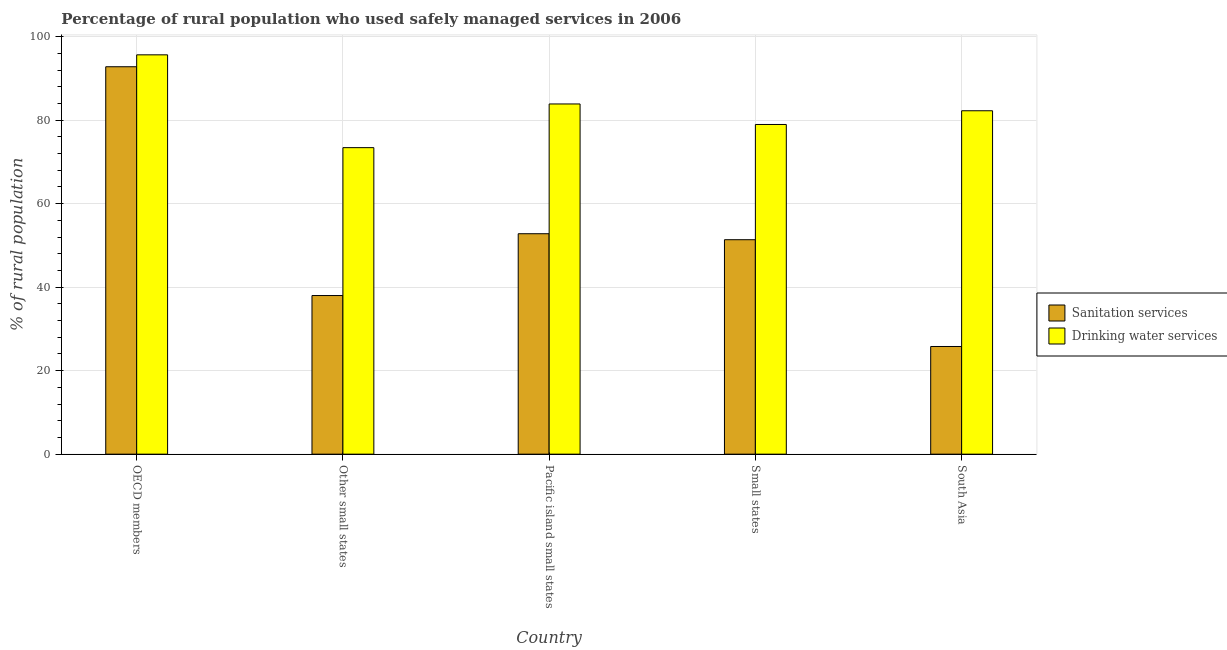How many groups of bars are there?
Offer a terse response. 5. Are the number of bars per tick equal to the number of legend labels?
Offer a very short reply. Yes. Are the number of bars on each tick of the X-axis equal?
Keep it short and to the point. Yes. How many bars are there on the 5th tick from the left?
Provide a succinct answer. 2. What is the label of the 3rd group of bars from the left?
Make the answer very short. Pacific island small states. In how many cases, is the number of bars for a given country not equal to the number of legend labels?
Ensure brevity in your answer.  0. What is the percentage of rural population who used drinking water services in South Asia?
Ensure brevity in your answer.  82.26. Across all countries, what is the maximum percentage of rural population who used sanitation services?
Your response must be concise. 92.8. Across all countries, what is the minimum percentage of rural population who used sanitation services?
Make the answer very short. 25.79. In which country was the percentage of rural population who used drinking water services maximum?
Keep it short and to the point. OECD members. What is the total percentage of rural population who used sanitation services in the graph?
Give a very brief answer. 260.76. What is the difference between the percentage of rural population who used sanitation services in Pacific island small states and that in South Asia?
Your answer should be very brief. 27.01. What is the difference between the percentage of rural population who used drinking water services in Pacific island small states and the percentage of rural population who used sanitation services in OECD members?
Offer a terse response. -8.92. What is the average percentage of rural population who used drinking water services per country?
Your answer should be very brief. 82.84. What is the difference between the percentage of rural population who used sanitation services and percentage of rural population who used drinking water services in Pacific island small states?
Offer a terse response. -31.08. What is the ratio of the percentage of rural population who used drinking water services in Other small states to that in Small states?
Provide a succinct answer. 0.93. Is the difference between the percentage of rural population who used sanitation services in OECD members and Other small states greater than the difference between the percentage of rural population who used drinking water services in OECD members and Other small states?
Keep it short and to the point. Yes. What is the difference between the highest and the second highest percentage of rural population who used sanitation services?
Provide a succinct answer. 40. What is the difference between the highest and the lowest percentage of rural population who used sanitation services?
Provide a short and direct response. 67.01. What does the 2nd bar from the left in Small states represents?
Your answer should be compact. Drinking water services. What does the 2nd bar from the right in Small states represents?
Your answer should be compact. Sanitation services. Are all the bars in the graph horizontal?
Provide a succinct answer. No. How many countries are there in the graph?
Keep it short and to the point. 5. Does the graph contain any zero values?
Ensure brevity in your answer.  No. Where does the legend appear in the graph?
Ensure brevity in your answer.  Center right. What is the title of the graph?
Ensure brevity in your answer.  Percentage of rural population who used safely managed services in 2006. What is the label or title of the Y-axis?
Offer a terse response. % of rural population. What is the % of rural population in Sanitation services in OECD members?
Ensure brevity in your answer.  92.8. What is the % of rural population of Drinking water services in OECD members?
Make the answer very short. 95.65. What is the % of rural population of Sanitation services in Other small states?
Keep it short and to the point. 38. What is the % of rural population in Drinking water services in Other small states?
Provide a short and direct response. 73.42. What is the % of rural population of Sanitation services in Pacific island small states?
Make the answer very short. 52.8. What is the % of rural population of Drinking water services in Pacific island small states?
Offer a very short reply. 83.88. What is the % of rural population of Sanitation services in Small states?
Offer a very short reply. 51.37. What is the % of rural population in Drinking water services in Small states?
Make the answer very short. 78.97. What is the % of rural population in Sanitation services in South Asia?
Provide a short and direct response. 25.79. What is the % of rural population in Drinking water services in South Asia?
Offer a terse response. 82.26. Across all countries, what is the maximum % of rural population in Sanitation services?
Offer a very short reply. 92.8. Across all countries, what is the maximum % of rural population of Drinking water services?
Ensure brevity in your answer.  95.65. Across all countries, what is the minimum % of rural population of Sanitation services?
Provide a short and direct response. 25.79. Across all countries, what is the minimum % of rural population in Drinking water services?
Ensure brevity in your answer.  73.42. What is the total % of rural population in Sanitation services in the graph?
Offer a terse response. 260.76. What is the total % of rural population of Drinking water services in the graph?
Provide a succinct answer. 414.19. What is the difference between the % of rural population in Sanitation services in OECD members and that in Other small states?
Ensure brevity in your answer.  54.8. What is the difference between the % of rural population of Drinking water services in OECD members and that in Other small states?
Provide a short and direct response. 22.23. What is the difference between the % of rural population in Sanitation services in OECD members and that in Pacific island small states?
Provide a short and direct response. 40. What is the difference between the % of rural population in Drinking water services in OECD members and that in Pacific island small states?
Ensure brevity in your answer.  11.77. What is the difference between the % of rural population in Sanitation services in OECD members and that in Small states?
Ensure brevity in your answer.  41.43. What is the difference between the % of rural population in Drinking water services in OECD members and that in Small states?
Your answer should be compact. 16.68. What is the difference between the % of rural population of Sanitation services in OECD members and that in South Asia?
Offer a very short reply. 67.01. What is the difference between the % of rural population in Drinking water services in OECD members and that in South Asia?
Make the answer very short. 13.4. What is the difference between the % of rural population of Sanitation services in Other small states and that in Pacific island small states?
Offer a very short reply. -14.8. What is the difference between the % of rural population of Drinking water services in Other small states and that in Pacific island small states?
Your response must be concise. -10.46. What is the difference between the % of rural population of Sanitation services in Other small states and that in Small states?
Your answer should be compact. -13.37. What is the difference between the % of rural population of Drinking water services in Other small states and that in Small states?
Your answer should be very brief. -5.55. What is the difference between the % of rural population of Sanitation services in Other small states and that in South Asia?
Your answer should be compact. 12.21. What is the difference between the % of rural population of Drinking water services in Other small states and that in South Asia?
Provide a succinct answer. -8.83. What is the difference between the % of rural population in Sanitation services in Pacific island small states and that in Small states?
Provide a succinct answer. 1.43. What is the difference between the % of rural population of Drinking water services in Pacific island small states and that in Small states?
Your answer should be very brief. 4.91. What is the difference between the % of rural population in Sanitation services in Pacific island small states and that in South Asia?
Provide a succinct answer. 27.01. What is the difference between the % of rural population in Drinking water services in Pacific island small states and that in South Asia?
Your answer should be very brief. 1.63. What is the difference between the % of rural population of Sanitation services in Small states and that in South Asia?
Ensure brevity in your answer.  25.58. What is the difference between the % of rural population in Drinking water services in Small states and that in South Asia?
Provide a succinct answer. -3.28. What is the difference between the % of rural population in Sanitation services in OECD members and the % of rural population in Drinking water services in Other small states?
Offer a very short reply. 19.38. What is the difference between the % of rural population in Sanitation services in OECD members and the % of rural population in Drinking water services in Pacific island small states?
Your answer should be very brief. 8.92. What is the difference between the % of rural population in Sanitation services in OECD members and the % of rural population in Drinking water services in Small states?
Your answer should be very brief. 13.83. What is the difference between the % of rural population of Sanitation services in OECD members and the % of rural population of Drinking water services in South Asia?
Provide a succinct answer. 10.54. What is the difference between the % of rural population of Sanitation services in Other small states and the % of rural population of Drinking water services in Pacific island small states?
Your answer should be compact. -45.89. What is the difference between the % of rural population of Sanitation services in Other small states and the % of rural population of Drinking water services in Small states?
Make the answer very short. -40.98. What is the difference between the % of rural population of Sanitation services in Other small states and the % of rural population of Drinking water services in South Asia?
Your response must be concise. -44.26. What is the difference between the % of rural population in Sanitation services in Pacific island small states and the % of rural population in Drinking water services in Small states?
Make the answer very short. -26.17. What is the difference between the % of rural population in Sanitation services in Pacific island small states and the % of rural population in Drinking water services in South Asia?
Offer a very short reply. -29.45. What is the difference between the % of rural population of Sanitation services in Small states and the % of rural population of Drinking water services in South Asia?
Make the answer very short. -30.89. What is the average % of rural population of Sanitation services per country?
Offer a terse response. 52.15. What is the average % of rural population of Drinking water services per country?
Your answer should be very brief. 82.84. What is the difference between the % of rural population in Sanitation services and % of rural population in Drinking water services in OECD members?
Keep it short and to the point. -2.85. What is the difference between the % of rural population in Sanitation services and % of rural population in Drinking water services in Other small states?
Your answer should be compact. -35.43. What is the difference between the % of rural population of Sanitation services and % of rural population of Drinking water services in Pacific island small states?
Keep it short and to the point. -31.08. What is the difference between the % of rural population of Sanitation services and % of rural population of Drinking water services in Small states?
Keep it short and to the point. -27.61. What is the difference between the % of rural population in Sanitation services and % of rural population in Drinking water services in South Asia?
Offer a terse response. -56.47. What is the ratio of the % of rural population in Sanitation services in OECD members to that in Other small states?
Provide a short and direct response. 2.44. What is the ratio of the % of rural population of Drinking water services in OECD members to that in Other small states?
Provide a succinct answer. 1.3. What is the ratio of the % of rural population of Sanitation services in OECD members to that in Pacific island small states?
Make the answer very short. 1.76. What is the ratio of the % of rural population of Drinking water services in OECD members to that in Pacific island small states?
Offer a very short reply. 1.14. What is the ratio of the % of rural population of Sanitation services in OECD members to that in Small states?
Provide a succinct answer. 1.81. What is the ratio of the % of rural population of Drinking water services in OECD members to that in Small states?
Offer a very short reply. 1.21. What is the ratio of the % of rural population in Sanitation services in OECD members to that in South Asia?
Ensure brevity in your answer.  3.6. What is the ratio of the % of rural population of Drinking water services in OECD members to that in South Asia?
Give a very brief answer. 1.16. What is the ratio of the % of rural population of Sanitation services in Other small states to that in Pacific island small states?
Offer a very short reply. 0.72. What is the ratio of the % of rural population in Drinking water services in Other small states to that in Pacific island small states?
Provide a short and direct response. 0.88. What is the ratio of the % of rural population of Sanitation services in Other small states to that in Small states?
Make the answer very short. 0.74. What is the ratio of the % of rural population of Drinking water services in Other small states to that in Small states?
Make the answer very short. 0.93. What is the ratio of the % of rural population in Sanitation services in Other small states to that in South Asia?
Your answer should be compact. 1.47. What is the ratio of the % of rural population in Drinking water services in Other small states to that in South Asia?
Keep it short and to the point. 0.89. What is the ratio of the % of rural population of Sanitation services in Pacific island small states to that in Small states?
Offer a very short reply. 1.03. What is the ratio of the % of rural population of Drinking water services in Pacific island small states to that in Small states?
Provide a succinct answer. 1.06. What is the ratio of the % of rural population of Sanitation services in Pacific island small states to that in South Asia?
Offer a terse response. 2.05. What is the ratio of the % of rural population in Drinking water services in Pacific island small states to that in South Asia?
Keep it short and to the point. 1.02. What is the ratio of the % of rural population of Sanitation services in Small states to that in South Asia?
Your response must be concise. 1.99. What is the ratio of the % of rural population in Drinking water services in Small states to that in South Asia?
Your answer should be compact. 0.96. What is the difference between the highest and the second highest % of rural population in Sanitation services?
Provide a short and direct response. 40. What is the difference between the highest and the second highest % of rural population of Drinking water services?
Your answer should be compact. 11.77. What is the difference between the highest and the lowest % of rural population of Sanitation services?
Your answer should be compact. 67.01. What is the difference between the highest and the lowest % of rural population of Drinking water services?
Your answer should be compact. 22.23. 